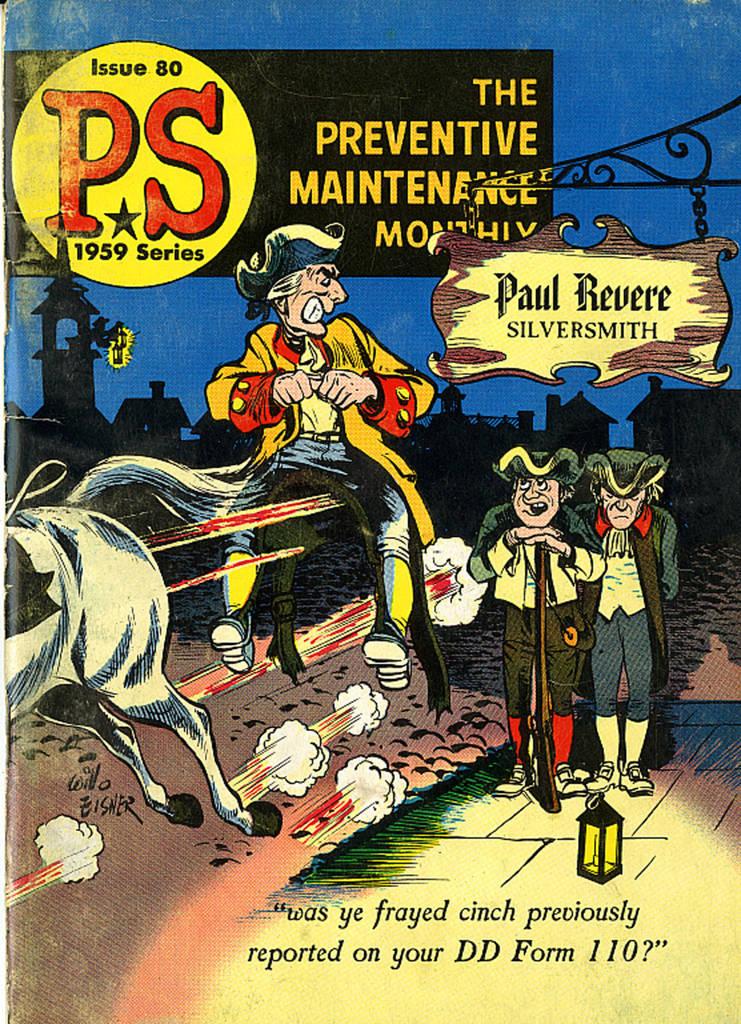What form is referenced?
Your answer should be very brief. Dd form 110. 